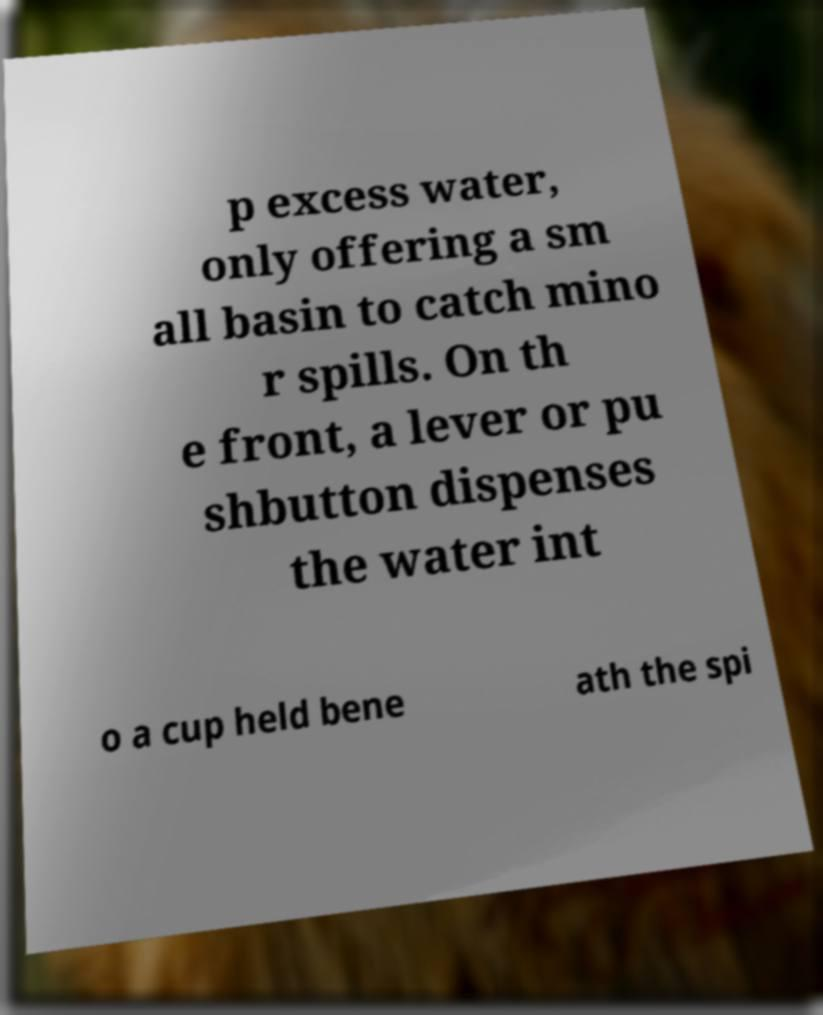Please read and relay the text visible in this image. What does it say? p excess water, only offering a sm all basin to catch mino r spills. On th e front, a lever or pu shbutton dispenses the water int o a cup held bene ath the spi 